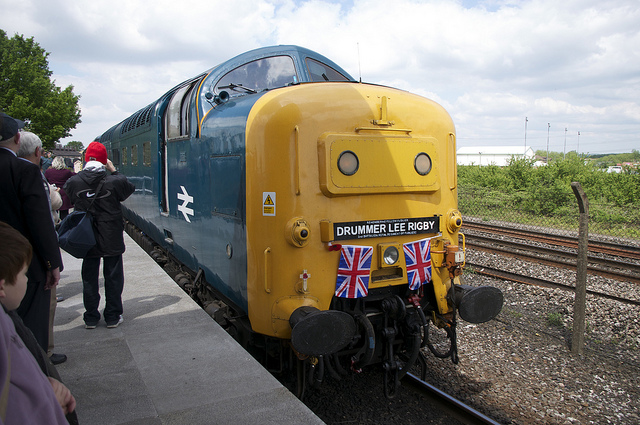Identify and read out the text in this image. DRUMMER LEE RIGBY 